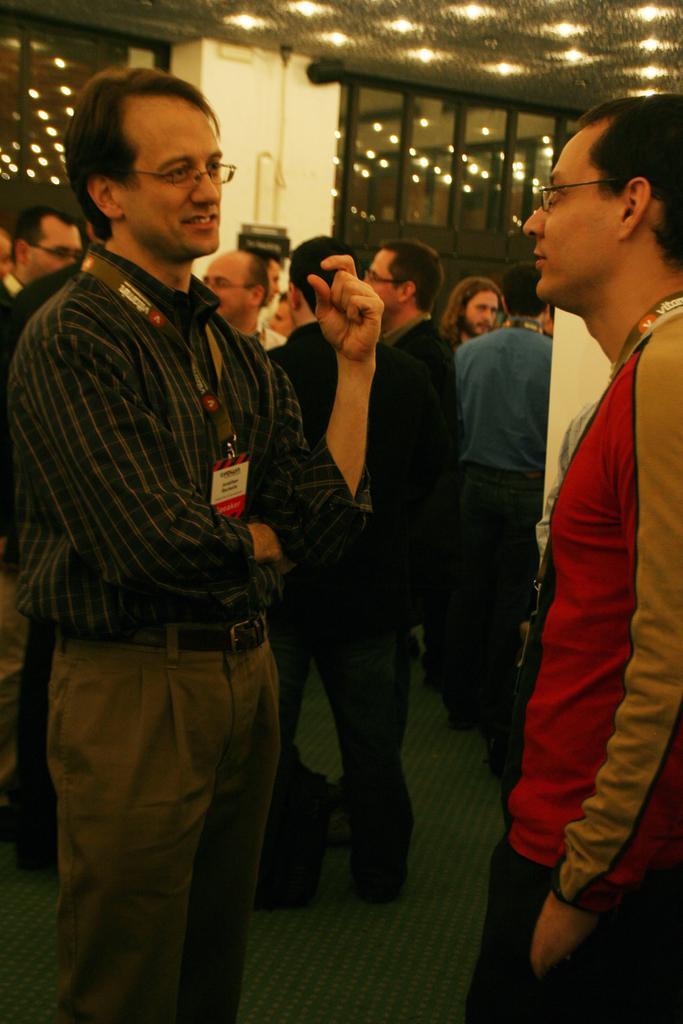Please provide a concise description of this image. In this picture we can see some people are standing, two persons in the front are wearing spectacles, in the background there are glasses, we can see lights at the top of the picture. 